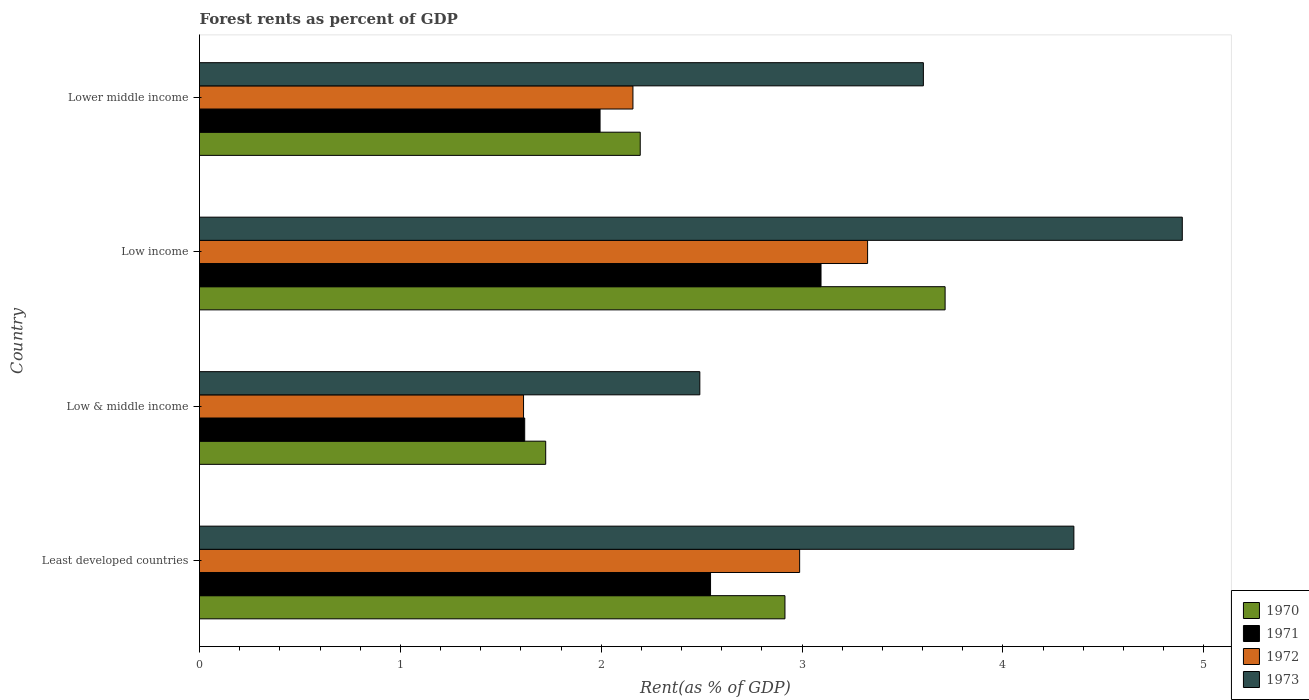How many different coloured bars are there?
Keep it short and to the point. 4. How many bars are there on the 1st tick from the top?
Offer a very short reply. 4. What is the label of the 1st group of bars from the top?
Keep it short and to the point. Lower middle income. What is the forest rent in 1973 in Least developed countries?
Keep it short and to the point. 4.35. Across all countries, what is the maximum forest rent in 1973?
Your response must be concise. 4.89. Across all countries, what is the minimum forest rent in 1973?
Offer a very short reply. 2.49. What is the total forest rent in 1970 in the graph?
Make the answer very short. 10.55. What is the difference between the forest rent in 1970 in Least developed countries and that in Low income?
Keep it short and to the point. -0.8. What is the difference between the forest rent in 1971 in Least developed countries and the forest rent in 1972 in Low income?
Keep it short and to the point. -0.78. What is the average forest rent in 1973 per country?
Keep it short and to the point. 3.84. What is the difference between the forest rent in 1973 and forest rent in 1970 in Lower middle income?
Offer a terse response. 1.41. In how many countries, is the forest rent in 1971 greater than 2 %?
Ensure brevity in your answer.  2. What is the ratio of the forest rent in 1971 in Least developed countries to that in Low & middle income?
Provide a succinct answer. 1.57. What is the difference between the highest and the second highest forest rent in 1971?
Offer a terse response. 0.55. What is the difference between the highest and the lowest forest rent in 1970?
Your response must be concise. 1.99. Is it the case that in every country, the sum of the forest rent in 1971 and forest rent in 1973 is greater than the sum of forest rent in 1972 and forest rent in 1970?
Provide a short and direct response. Yes. What does the 2nd bar from the bottom in Low & middle income represents?
Your response must be concise. 1971. How many countries are there in the graph?
Your answer should be very brief. 4. What is the difference between two consecutive major ticks on the X-axis?
Make the answer very short. 1. Does the graph contain grids?
Offer a very short reply. No. How many legend labels are there?
Your answer should be very brief. 4. What is the title of the graph?
Provide a short and direct response. Forest rents as percent of GDP. Does "1983" appear as one of the legend labels in the graph?
Make the answer very short. No. What is the label or title of the X-axis?
Your response must be concise. Rent(as % of GDP). What is the label or title of the Y-axis?
Offer a terse response. Country. What is the Rent(as % of GDP) of 1970 in Least developed countries?
Your response must be concise. 2.92. What is the Rent(as % of GDP) of 1971 in Least developed countries?
Your answer should be very brief. 2.54. What is the Rent(as % of GDP) of 1972 in Least developed countries?
Offer a terse response. 2.99. What is the Rent(as % of GDP) in 1973 in Least developed countries?
Keep it short and to the point. 4.35. What is the Rent(as % of GDP) in 1970 in Low & middle income?
Offer a terse response. 1.72. What is the Rent(as % of GDP) of 1971 in Low & middle income?
Provide a short and direct response. 1.62. What is the Rent(as % of GDP) of 1972 in Low & middle income?
Give a very brief answer. 1.61. What is the Rent(as % of GDP) in 1973 in Low & middle income?
Provide a short and direct response. 2.49. What is the Rent(as % of GDP) in 1970 in Low income?
Ensure brevity in your answer.  3.71. What is the Rent(as % of GDP) in 1971 in Low income?
Your answer should be compact. 3.09. What is the Rent(as % of GDP) of 1972 in Low income?
Provide a succinct answer. 3.33. What is the Rent(as % of GDP) in 1973 in Low income?
Ensure brevity in your answer.  4.89. What is the Rent(as % of GDP) in 1970 in Lower middle income?
Provide a short and direct response. 2.19. What is the Rent(as % of GDP) of 1971 in Lower middle income?
Your answer should be very brief. 1.99. What is the Rent(as % of GDP) of 1972 in Lower middle income?
Your response must be concise. 2.16. What is the Rent(as % of GDP) of 1973 in Lower middle income?
Your answer should be very brief. 3.6. Across all countries, what is the maximum Rent(as % of GDP) in 1970?
Offer a terse response. 3.71. Across all countries, what is the maximum Rent(as % of GDP) in 1971?
Keep it short and to the point. 3.09. Across all countries, what is the maximum Rent(as % of GDP) of 1972?
Your response must be concise. 3.33. Across all countries, what is the maximum Rent(as % of GDP) in 1973?
Give a very brief answer. 4.89. Across all countries, what is the minimum Rent(as % of GDP) of 1970?
Give a very brief answer. 1.72. Across all countries, what is the minimum Rent(as % of GDP) of 1971?
Ensure brevity in your answer.  1.62. Across all countries, what is the minimum Rent(as % of GDP) in 1972?
Provide a short and direct response. 1.61. Across all countries, what is the minimum Rent(as % of GDP) of 1973?
Provide a succinct answer. 2.49. What is the total Rent(as % of GDP) of 1970 in the graph?
Your response must be concise. 10.55. What is the total Rent(as % of GDP) of 1971 in the graph?
Your answer should be compact. 9.25. What is the total Rent(as % of GDP) in 1972 in the graph?
Offer a terse response. 10.09. What is the total Rent(as % of GDP) in 1973 in the graph?
Provide a short and direct response. 15.34. What is the difference between the Rent(as % of GDP) in 1970 in Least developed countries and that in Low & middle income?
Your response must be concise. 1.19. What is the difference between the Rent(as % of GDP) in 1971 in Least developed countries and that in Low & middle income?
Provide a succinct answer. 0.93. What is the difference between the Rent(as % of GDP) in 1972 in Least developed countries and that in Low & middle income?
Your response must be concise. 1.37. What is the difference between the Rent(as % of GDP) of 1973 in Least developed countries and that in Low & middle income?
Offer a very short reply. 1.86. What is the difference between the Rent(as % of GDP) in 1970 in Least developed countries and that in Low income?
Your answer should be very brief. -0.8. What is the difference between the Rent(as % of GDP) of 1971 in Least developed countries and that in Low income?
Offer a terse response. -0.55. What is the difference between the Rent(as % of GDP) of 1972 in Least developed countries and that in Low income?
Make the answer very short. -0.34. What is the difference between the Rent(as % of GDP) in 1973 in Least developed countries and that in Low income?
Offer a terse response. -0.54. What is the difference between the Rent(as % of GDP) of 1970 in Least developed countries and that in Lower middle income?
Make the answer very short. 0.72. What is the difference between the Rent(as % of GDP) in 1971 in Least developed countries and that in Lower middle income?
Your answer should be compact. 0.55. What is the difference between the Rent(as % of GDP) in 1972 in Least developed countries and that in Lower middle income?
Your answer should be compact. 0.83. What is the difference between the Rent(as % of GDP) in 1973 in Least developed countries and that in Lower middle income?
Give a very brief answer. 0.75. What is the difference between the Rent(as % of GDP) in 1970 in Low & middle income and that in Low income?
Give a very brief answer. -1.99. What is the difference between the Rent(as % of GDP) in 1971 in Low & middle income and that in Low income?
Offer a terse response. -1.48. What is the difference between the Rent(as % of GDP) of 1972 in Low & middle income and that in Low income?
Offer a very short reply. -1.71. What is the difference between the Rent(as % of GDP) of 1973 in Low & middle income and that in Low income?
Give a very brief answer. -2.4. What is the difference between the Rent(as % of GDP) of 1970 in Low & middle income and that in Lower middle income?
Make the answer very short. -0.47. What is the difference between the Rent(as % of GDP) of 1971 in Low & middle income and that in Lower middle income?
Make the answer very short. -0.38. What is the difference between the Rent(as % of GDP) in 1972 in Low & middle income and that in Lower middle income?
Your answer should be compact. -0.54. What is the difference between the Rent(as % of GDP) of 1973 in Low & middle income and that in Lower middle income?
Offer a very short reply. -1.11. What is the difference between the Rent(as % of GDP) in 1970 in Low income and that in Lower middle income?
Make the answer very short. 1.52. What is the difference between the Rent(as % of GDP) of 1971 in Low income and that in Lower middle income?
Give a very brief answer. 1.1. What is the difference between the Rent(as % of GDP) of 1972 in Low income and that in Lower middle income?
Offer a terse response. 1.17. What is the difference between the Rent(as % of GDP) in 1973 in Low income and that in Lower middle income?
Your response must be concise. 1.29. What is the difference between the Rent(as % of GDP) in 1970 in Least developed countries and the Rent(as % of GDP) in 1971 in Low & middle income?
Your answer should be very brief. 1.3. What is the difference between the Rent(as % of GDP) in 1970 in Least developed countries and the Rent(as % of GDP) in 1972 in Low & middle income?
Provide a succinct answer. 1.3. What is the difference between the Rent(as % of GDP) in 1970 in Least developed countries and the Rent(as % of GDP) in 1973 in Low & middle income?
Offer a very short reply. 0.42. What is the difference between the Rent(as % of GDP) of 1971 in Least developed countries and the Rent(as % of GDP) of 1972 in Low & middle income?
Your answer should be compact. 0.93. What is the difference between the Rent(as % of GDP) in 1971 in Least developed countries and the Rent(as % of GDP) in 1973 in Low & middle income?
Your answer should be compact. 0.05. What is the difference between the Rent(as % of GDP) in 1972 in Least developed countries and the Rent(as % of GDP) in 1973 in Low & middle income?
Your answer should be compact. 0.5. What is the difference between the Rent(as % of GDP) in 1970 in Least developed countries and the Rent(as % of GDP) in 1971 in Low income?
Your answer should be very brief. -0.18. What is the difference between the Rent(as % of GDP) of 1970 in Least developed countries and the Rent(as % of GDP) of 1972 in Low income?
Keep it short and to the point. -0.41. What is the difference between the Rent(as % of GDP) in 1970 in Least developed countries and the Rent(as % of GDP) in 1973 in Low income?
Offer a terse response. -1.98. What is the difference between the Rent(as % of GDP) of 1971 in Least developed countries and the Rent(as % of GDP) of 1972 in Low income?
Ensure brevity in your answer.  -0.78. What is the difference between the Rent(as % of GDP) in 1971 in Least developed countries and the Rent(as % of GDP) in 1973 in Low income?
Offer a very short reply. -2.35. What is the difference between the Rent(as % of GDP) in 1972 in Least developed countries and the Rent(as % of GDP) in 1973 in Low income?
Your answer should be compact. -1.91. What is the difference between the Rent(as % of GDP) in 1970 in Least developed countries and the Rent(as % of GDP) in 1971 in Lower middle income?
Give a very brief answer. 0.92. What is the difference between the Rent(as % of GDP) in 1970 in Least developed countries and the Rent(as % of GDP) in 1972 in Lower middle income?
Give a very brief answer. 0.76. What is the difference between the Rent(as % of GDP) of 1970 in Least developed countries and the Rent(as % of GDP) of 1973 in Lower middle income?
Your answer should be very brief. -0.69. What is the difference between the Rent(as % of GDP) in 1971 in Least developed countries and the Rent(as % of GDP) in 1972 in Lower middle income?
Ensure brevity in your answer.  0.39. What is the difference between the Rent(as % of GDP) in 1971 in Least developed countries and the Rent(as % of GDP) in 1973 in Lower middle income?
Offer a terse response. -1.06. What is the difference between the Rent(as % of GDP) in 1972 in Least developed countries and the Rent(as % of GDP) in 1973 in Lower middle income?
Provide a succinct answer. -0.62. What is the difference between the Rent(as % of GDP) in 1970 in Low & middle income and the Rent(as % of GDP) in 1971 in Low income?
Keep it short and to the point. -1.37. What is the difference between the Rent(as % of GDP) of 1970 in Low & middle income and the Rent(as % of GDP) of 1972 in Low income?
Give a very brief answer. -1.6. What is the difference between the Rent(as % of GDP) of 1970 in Low & middle income and the Rent(as % of GDP) of 1973 in Low income?
Your answer should be very brief. -3.17. What is the difference between the Rent(as % of GDP) of 1971 in Low & middle income and the Rent(as % of GDP) of 1972 in Low income?
Make the answer very short. -1.71. What is the difference between the Rent(as % of GDP) of 1971 in Low & middle income and the Rent(as % of GDP) of 1973 in Low income?
Your answer should be very brief. -3.27. What is the difference between the Rent(as % of GDP) in 1972 in Low & middle income and the Rent(as % of GDP) in 1973 in Low income?
Your answer should be compact. -3.28. What is the difference between the Rent(as % of GDP) in 1970 in Low & middle income and the Rent(as % of GDP) in 1971 in Lower middle income?
Offer a terse response. -0.27. What is the difference between the Rent(as % of GDP) in 1970 in Low & middle income and the Rent(as % of GDP) in 1972 in Lower middle income?
Offer a terse response. -0.43. What is the difference between the Rent(as % of GDP) of 1970 in Low & middle income and the Rent(as % of GDP) of 1973 in Lower middle income?
Provide a short and direct response. -1.88. What is the difference between the Rent(as % of GDP) of 1971 in Low & middle income and the Rent(as % of GDP) of 1972 in Lower middle income?
Your answer should be very brief. -0.54. What is the difference between the Rent(as % of GDP) of 1971 in Low & middle income and the Rent(as % of GDP) of 1973 in Lower middle income?
Make the answer very short. -1.99. What is the difference between the Rent(as % of GDP) in 1972 in Low & middle income and the Rent(as % of GDP) in 1973 in Lower middle income?
Your answer should be compact. -1.99. What is the difference between the Rent(as % of GDP) of 1970 in Low income and the Rent(as % of GDP) of 1971 in Lower middle income?
Give a very brief answer. 1.72. What is the difference between the Rent(as % of GDP) in 1970 in Low income and the Rent(as % of GDP) in 1972 in Lower middle income?
Your response must be concise. 1.55. What is the difference between the Rent(as % of GDP) in 1970 in Low income and the Rent(as % of GDP) in 1973 in Lower middle income?
Offer a terse response. 0.11. What is the difference between the Rent(as % of GDP) in 1971 in Low income and the Rent(as % of GDP) in 1972 in Lower middle income?
Provide a succinct answer. 0.94. What is the difference between the Rent(as % of GDP) of 1971 in Low income and the Rent(as % of GDP) of 1973 in Lower middle income?
Your response must be concise. -0.51. What is the difference between the Rent(as % of GDP) of 1972 in Low income and the Rent(as % of GDP) of 1973 in Lower middle income?
Your answer should be very brief. -0.28. What is the average Rent(as % of GDP) in 1970 per country?
Offer a very short reply. 2.64. What is the average Rent(as % of GDP) in 1971 per country?
Keep it short and to the point. 2.31. What is the average Rent(as % of GDP) in 1972 per country?
Your answer should be very brief. 2.52. What is the average Rent(as % of GDP) of 1973 per country?
Your answer should be very brief. 3.84. What is the difference between the Rent(as % of GDP) of 1970 and Rent(as % of GDP) of 1971 in Least developed countries?
Your answer should be very brief. 0.37. What is the difference between the Rent(as % of GDP) in 1970 and Rent(as % of GDP) in 1972 in Least developed countries?
Ensure brevity in your answer.  -0.07. What is the difference between the Rent(as % of GDP) in 1970 and Rent(as % of GDP) in 1973 in Least developed countries?
Your response must be concise. -1.44. What is the difference between the Rent(as % of GDP) in 1971 and Rent(as % of GDP) in 1972 in Least developed countries?
Your answer should be compact. -0.44. What is the difference between the Rent(as % of GDP) in 1971 and Rent(as % of GDP) in 1973 in Least developed countries?
Offer a terse response. -1.81. What is the difference between the Rent(as % of GDP) in 1972 and Rent(as % of GDP) in 1973 in Least developed countries?
Your answer should be very brief. -1.37. What is the difference between the Rent(as % of GDP) in 1970 and Rent(as % of GDP) in 1971 in Low & middle income?
Provide a succinct answer. 0.1. What is the difference between the Rent(as % of GDP) of 1970 and Rent(as % of GDP) of 1972 in Low & middle income?
Your response must be concise. 0.11. What is the difference between the Rent(as % of GDP) in 1970 and Rent(as % of GDP) in 1973 in Low & middle income?
Make the answer very short. -0.77. What is the difference between the Rent(as % of GDP) in 1971 and Rent(as % of GDP) in 1972 in Low & middle income?
Your response must be concise. 0.01. What is the difference between the Rent(as % of GDP) of 1971 and Rent(as % of GDP) of 1973 in Low & middle income?
Your answer should be very brief. -0.87. What is the difference between the Rent(as % of GDP) in 1972 and Rent(as % of GDP) in 1973 in Low & middle income?
Your answer should be very brief. -0.88. What is the difference between the Rent(as % of GDP) in 1970 and Rent(as % of GDP) in 1971 in Low income?
Your answer should be compact. 0.62. What is the difference between the Rent(as % of GDP) of 1970 and Rent(as % of GDP) of 1972 in Low income?
Your answer should be very brief. 0.39. What is the difference between the Rent(as % of GDP) in 1970 and Rent(as % of GDP) in 1973 in Low income?
Provide a short and direct response. -1.18. What is the difference between the Rent(as % of GDP) of 1971 and Rent(as % of GDP) of 1972 in Low income?
Offer a very short reply. -0.23. What is the difference between the Rent(as % of GDP) in 1971 and Rent(as % of GDP) in 1973 in Low income?
Provide a short and direct response. -1.8. What is the difference between the Rent(as % of GDP) of 1972 and Rent(as % of GDP) of 1973 in Low income?
Make the answer very short. -1.57. What is the difference between the Rent(as % of GDP) of 1970 and Rent(as % of GDP) of 1972 in Lower middle income?
Your response must be concise. 0.04. What is the difference between the Rent(as % of GDP) of 1970 and Rent(as % of GDP) of 1973 in Lower middle income?
Provide a short and direct response. -1.41. What is the difference between the Rent(as % of GDP) in 1971 and Rent(as % of GDP) in 1972 in Lower middle income?
Provide a succinct answer. -0.16. What is the difference between the Rent(as % of GDP) in 1971 and Rent(as % of GDP) in 1973 in Lower middle income?
Keep it short and to the point. -1.61. What is the difference between the Rent(as % of GDP) of 1972 and Rent(as % of GDP) of 1973 in Lower middle income?
Your answer should be compact. -1.45. What is the ratio of the Rent(as % of GDP) of 1970 in Least developed countries to that in Low & middle income?
Keep it short and to the point. 1.69. What is the ratio of the Rent(as % of GDP) in 1971 in Least developed countries to that in Low & middle income?
Offer a terse response. 1.57. What is the ratio of the Rent(as % of GDP) in 1972 in Least developed countries to that in Low & middle income?
Offer a terse response. 1.85. What is the ratio of the Rent(as % of GDP) in 1973 in Least developed countries to that in Low & middle income?
Provide a short and direct response. 1.75. What is the ratio of the Rent(as % of GDP) in 1970 in Least developed countries to that in Low income?
Offer a terse response. 0.79. What is the ratio of the Rent(as % of GDP) in 1971 in Least developed countries to that in Low income?
Give a very brief answer. 0.82. What is the ratio of the Rent(as % of GDP) of 1972 in Least developed countries to that in Low income?
Make the answer very short. 0.9. What is the ratio of the Rent(as % of GDP) in 1973 in Least developed countries to that in Low income?
Your answer should be very brief. 0.89. What is the ratio of the Rent(as % of GDP) in 1970 in Least developed countries to that in Lower middle income?
Offer a terse response. 1.33. What is the ratio of the Rent(as % of GDP) of 1971 in Least developed countries to that in Lower middle income?
Your answer should be compact. 1.28. What is the ratio of the Rent(as % of GDP) in 1972 in Least developed countries to that in Lower middle income?
Your response must be concise. 1.38. What is the ratio of the Rent(as % of GDP) in 1973 in Least developed countries to that in Lower middle income?
Offer a very short reply. 1.21. What is the ratio of the Rent(as % of GDP) in 1970 in Low & middle income to that in Low income?
Give a very brief answer. 0.46. What is the ratio of the Rent(as % of GDP) in 1971 in Low & middle income to that in Low income?
Provide a short and direct response. 0.52. What is the ratio of the Rent(as % of GDP) in 1972 in Low & middle income to that in Low income?
Offer a very short reply. 0.48. What is the ratio of the Rent(as % of GDP) in 1973 in Low & middle income to that in Low income?
Make the answer very short. 0.51. What is the ratio of the Rent(as % of GDP) of 1970 in Low & middle income to that in Lower middle income?
Offer a very short reply. 0.79. What is the ratio of the Rent(as % of GDP) of 1971 in Low & middle income to that in Lower middle income?
Your answer should be compact. 0.81. What is the ratio of the Rent(as % of GDP) of 1972 in Low & middle income to that in Lower middle income?
Your answer should be compact. 0.75. What is the ratio of the Rent(as % of GDP) in 1973 in Low & middle income to that in Lower middle income?
Ensure brevity in your answer.  0.69. What is the ratio of the Rent(as % of GDP) in 1970 in Low income to that in Lower middle income?
Make the answer very short. 1.69. What is the ratio of the Rent(as % of GDP) in 1971 in Low income to that in Lower middle income?
Give a very brief answer. 1.55. What is the ratio of the Rent(as % of GDP) of 1972 in Low income to that in Lower middle income?
Provide a short and direct response. 1.54. What is the ratio of the Rent(as % of GDP) of 1973 in Low income to that in Lower middle income?
Your answer should be very brief. 1.36. What is the difference between the highest and the second highest Rent(as % of GDP) of 1970?
Your response must be concise. 0.8. What is the difference between the highest and the second highest Rent(as % of GDP) in 1971?
Offer a terse response. 0.55. What is the difference between the highest and the second highest Rent(as % of GDP) in 1972?
Make the answer very short. 0.34. What is the difference between the highest and the second highest Rent(as % of GDP) in 1973?
Your answer should be very brief. 0.54. What is the difference between the highest and the lowest Rent(as % of GDP) in 1970?
Your answer should be very brief. 1.99. What is the difference between the highest and the lowest Rent(as % of GDP) in 1971?
Your answer should be very brief. 1.48. What is the difference between the highest and the lowest Rent(as % of GDP) in 1972?
Provide a short and direct response. 1.71. What is the difference between the highest and the lowest Rent(as % of GDP) in 1973?
Make the answer very short. 2.4. 